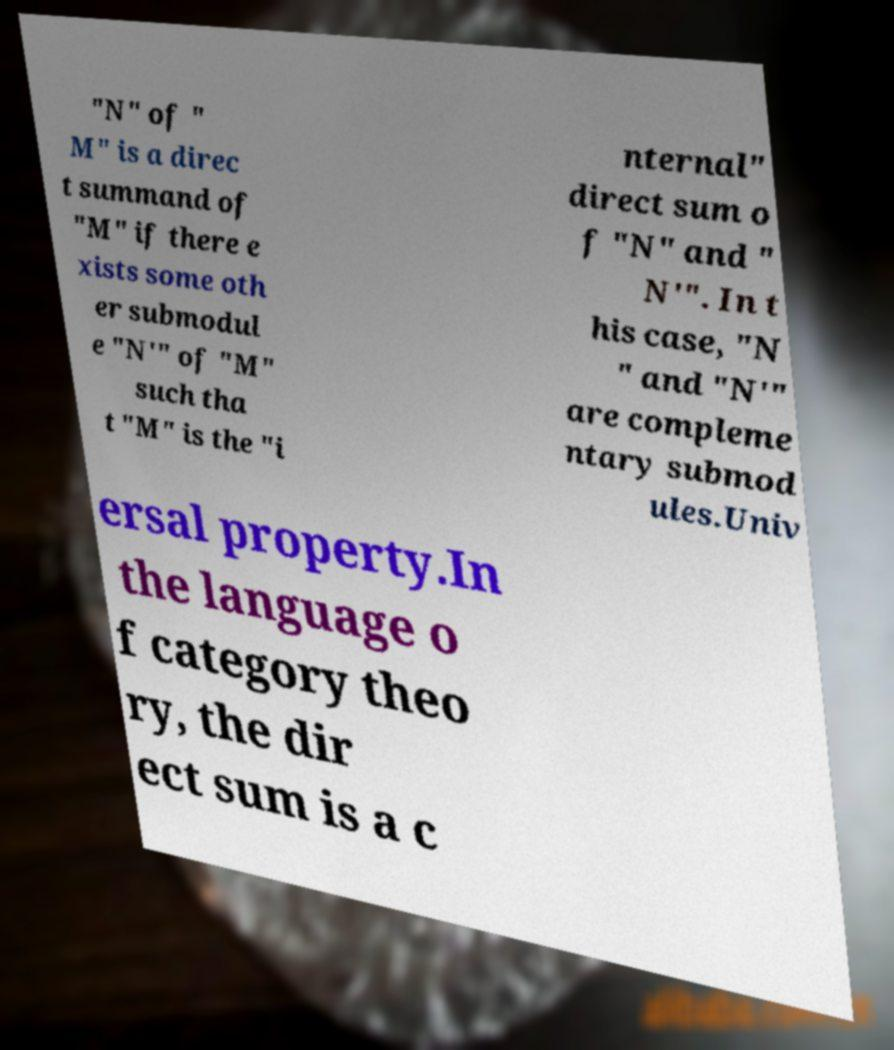Please identify and transcribe the text found in this image. "N" of " M" is a direc t summand of "M" if there e xists some oth er submodul e "N′" of "M" such tha t "M" is the "i nternal" direct sum o f "N" and " N′". In t his case, "N " and "N′" are compleme ntary submod ules.Univ ersal property.In the language o f category theo ry, the dir ect sum is a c 